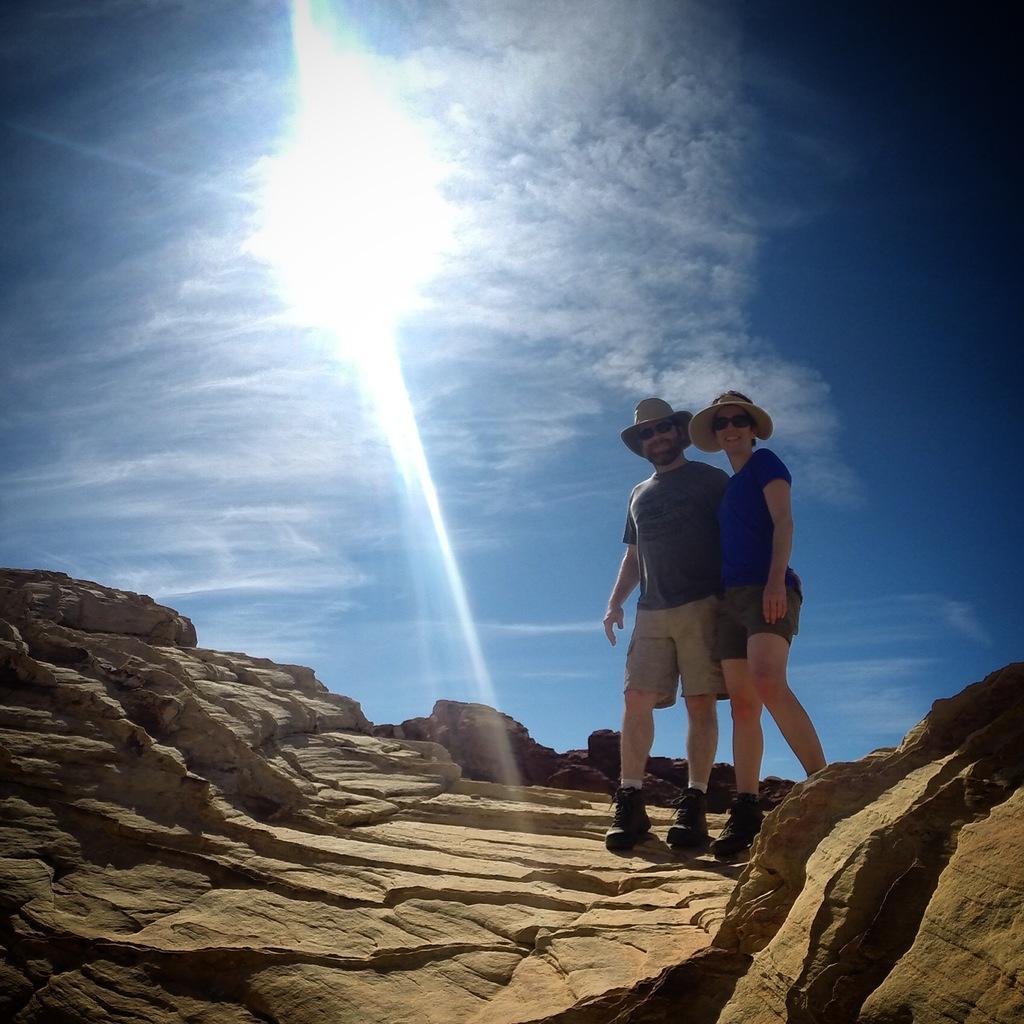How would you summarize this image in a sentence or two? In the picture I can see a woman and a man are standing on rocks. These people are wearing hats, black color shades, shirts, shorts and footwear. In the background I can see the sky and the sun. 